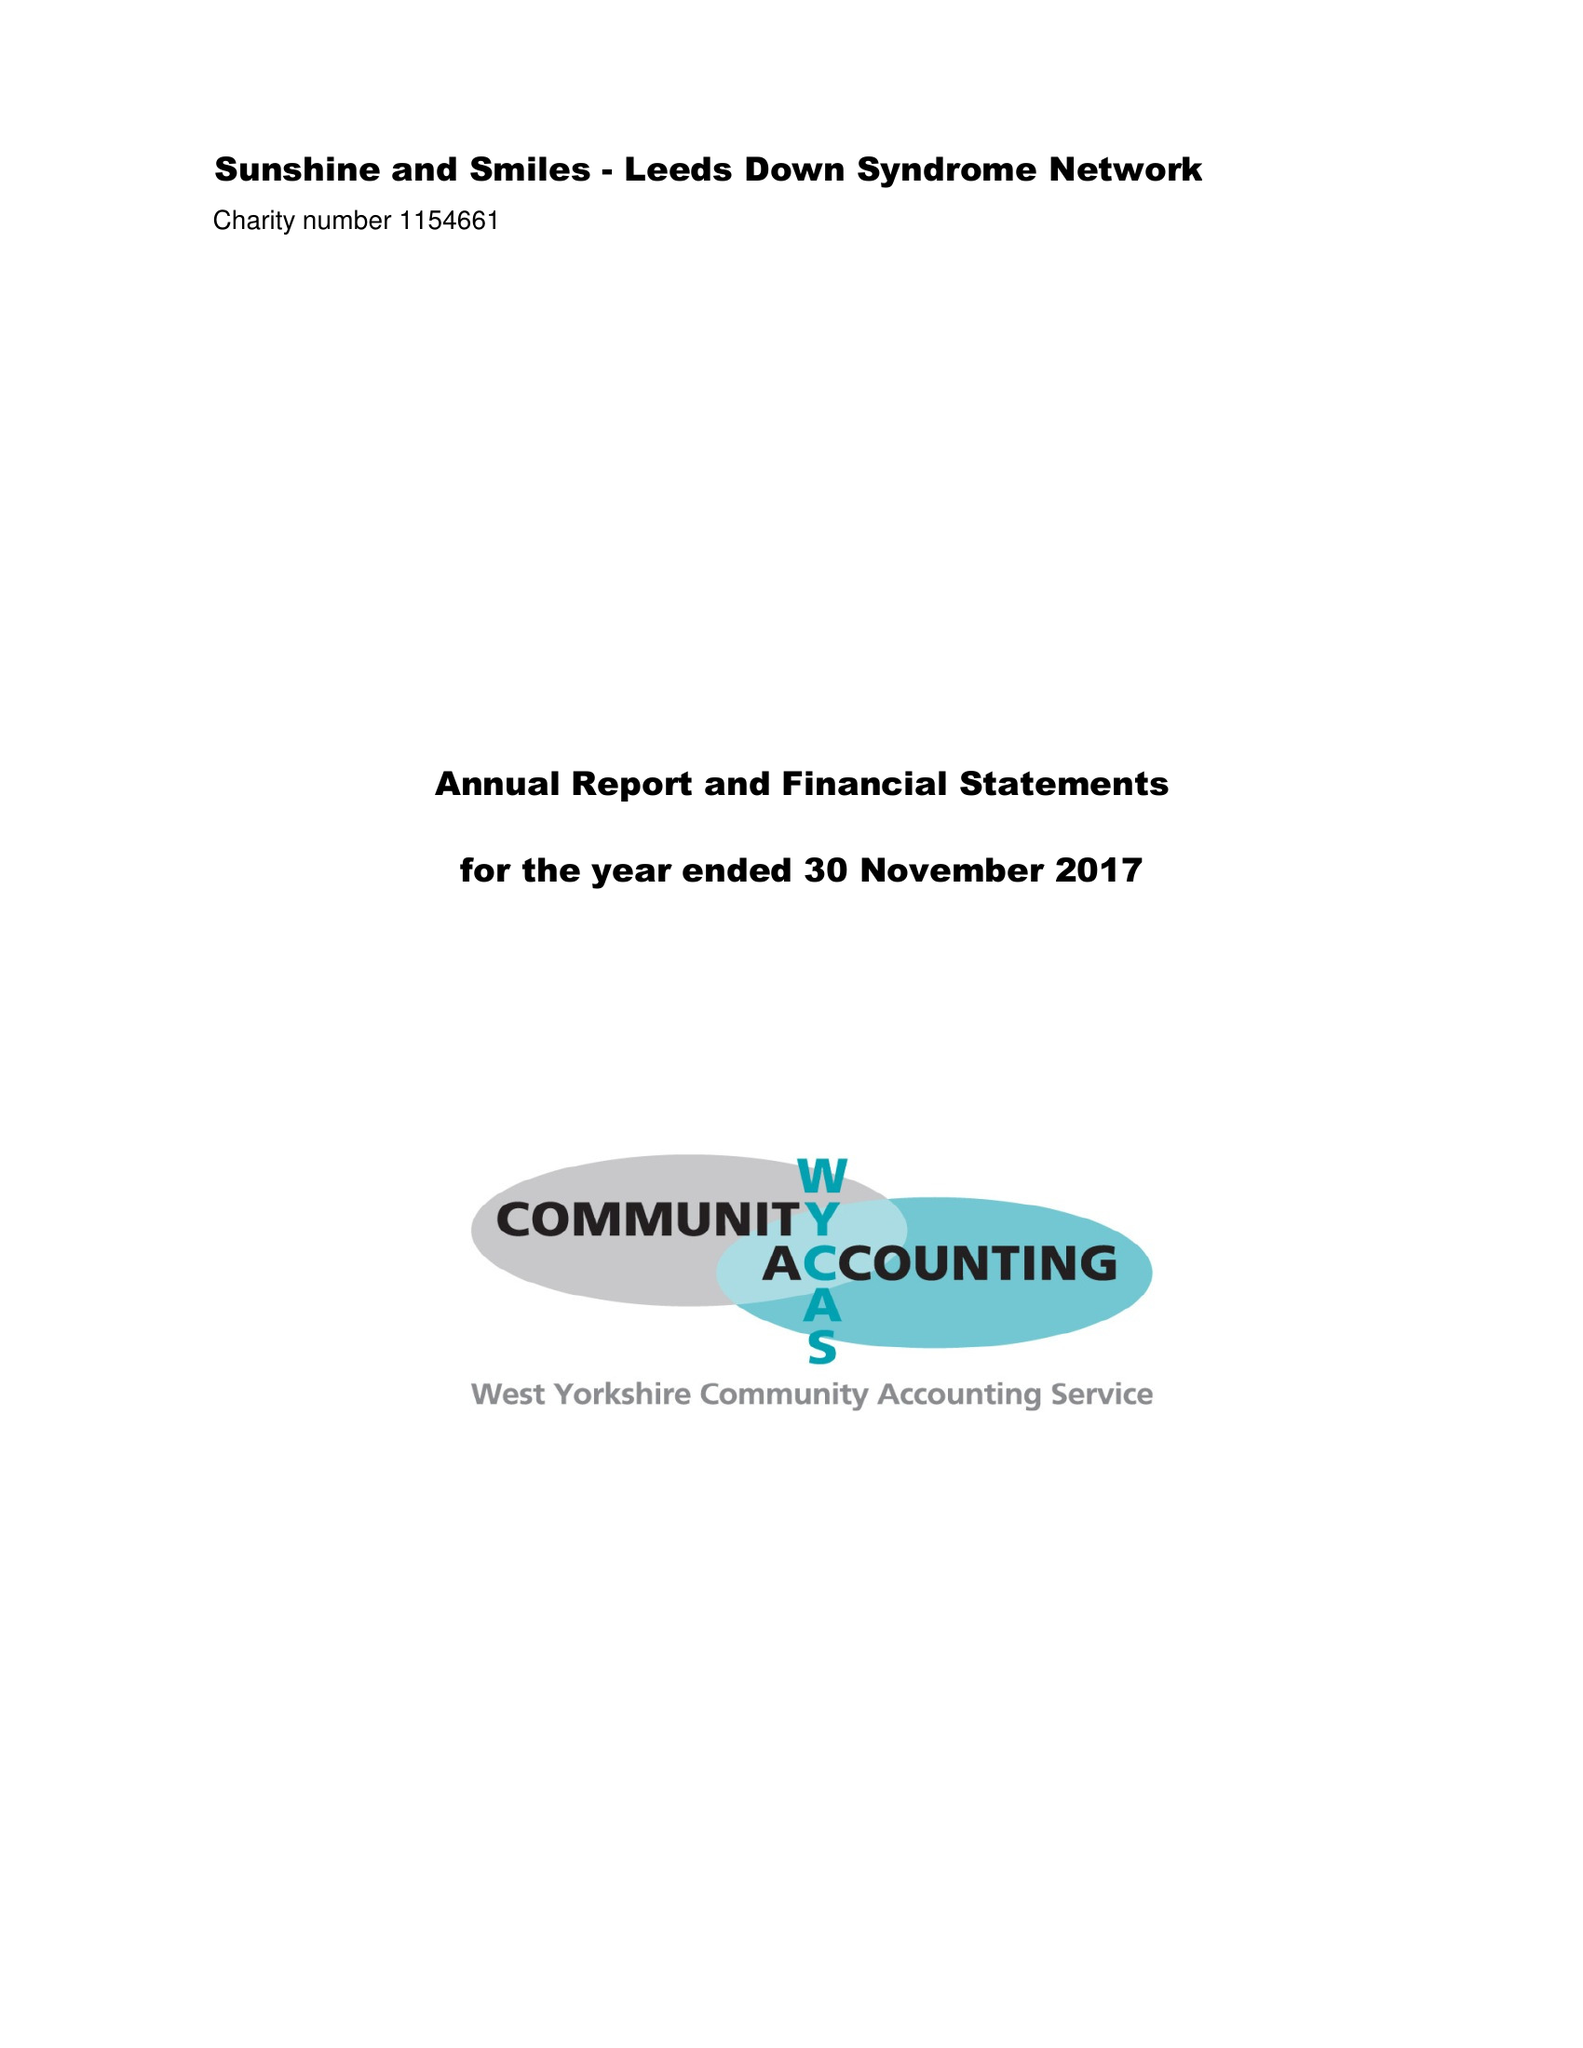What is the value for the report_date?
Answer the question using a single word or phrase. 2017-11-30 